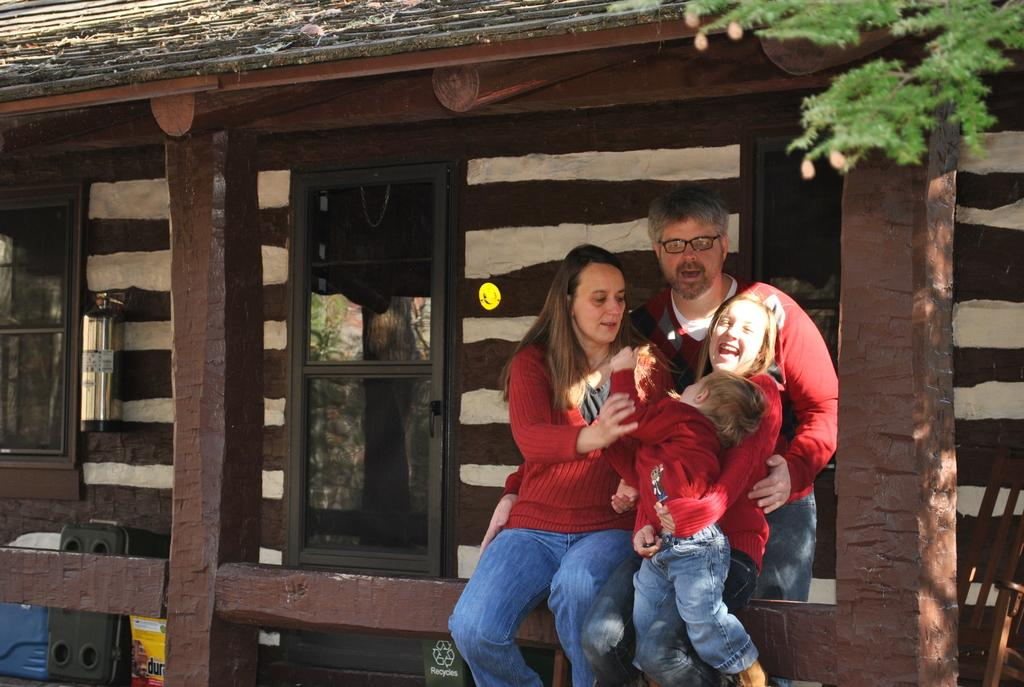How many persons are visible in the image? There are persons in the image, but the exact number is not specified. Where are the persons located in the image? The persons are in the middle of the image. What can be seen in the background of the image? There is a house in the background of the image. How many spiders are crawling on the persons' legs in the image? There is no mention of spiders or legs in the image, so it is not possible to answer this question. 